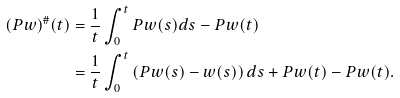<formula> <loc_0><loc_0><loc_500><loc_500>( P w ) ^ { \# } ( t ) & = \frac { 1 } { t } \int _ { 0 } ^ { t } P w ( s ) d s - P w ( t ) \\ & = \frac { 1 } { t } \int _ { 0 } ^ { t } \left ( P w ( s ) - w ( s ) \right ) d s + P w ( t ) - P w ( t ) .</formula> 